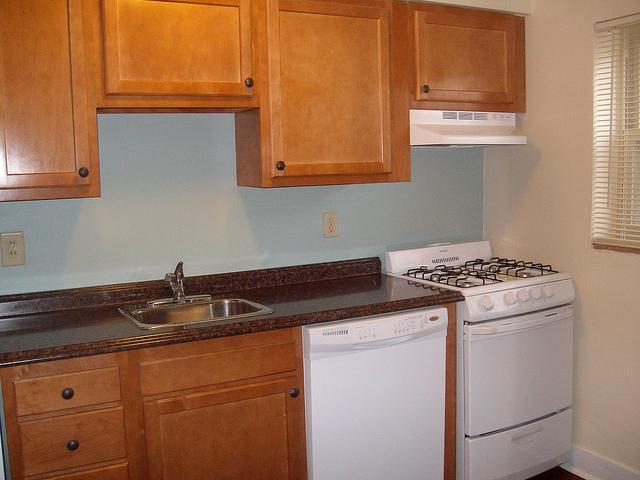How many appliances are shown?
Give a very brief answer. 2. How many people are on the field?
Give a very brief answer. 0. 